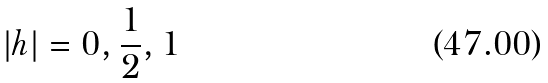Convert formula to latex. <formula><loc_0><loc_0><loc_500><loc_500>| h | = 0 , \frac { 1 } { 2 } , 1</formula> 